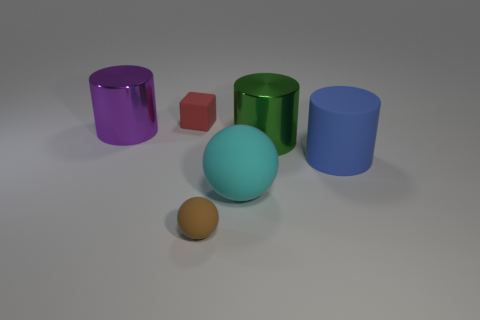There is a tiny cube that is the same material as the blue object; what color is it?
Make the answer very short. Red. Are there fewer green metallic cylinders than small green objects?
Your answer should be very brief. No. There is a big object that is both left of the big green metallic object and to the right of the red thing; what material is it?
Keep it short and to the point. Rubber. There is a large shiny cylinder on the left side of the brown ball; is there a purple metal cylinder that is left of it?
Your answer should be compact. No. What number of big cylinders have the same color as the big sphere?
Your response must be concise. 0. Is the large cyan ball made of the same material as the large green thing?
Your response must be concise. No. Are there any spheres to the right of the brown object?
Offer a terse response. Yes. The large cylinder that is on the left side of the ball that is in front of the cyan rubber thing is made of what material?
Provide a short and direct response. Metal. The blue object that is the same shape as the large green thing is what size?
Make the answer very short. Large. There is a rubber object that is on the left side of the big rubber sphere and in front of the tiny red object; what color is it?
Keep it short and to the point. Brown. 